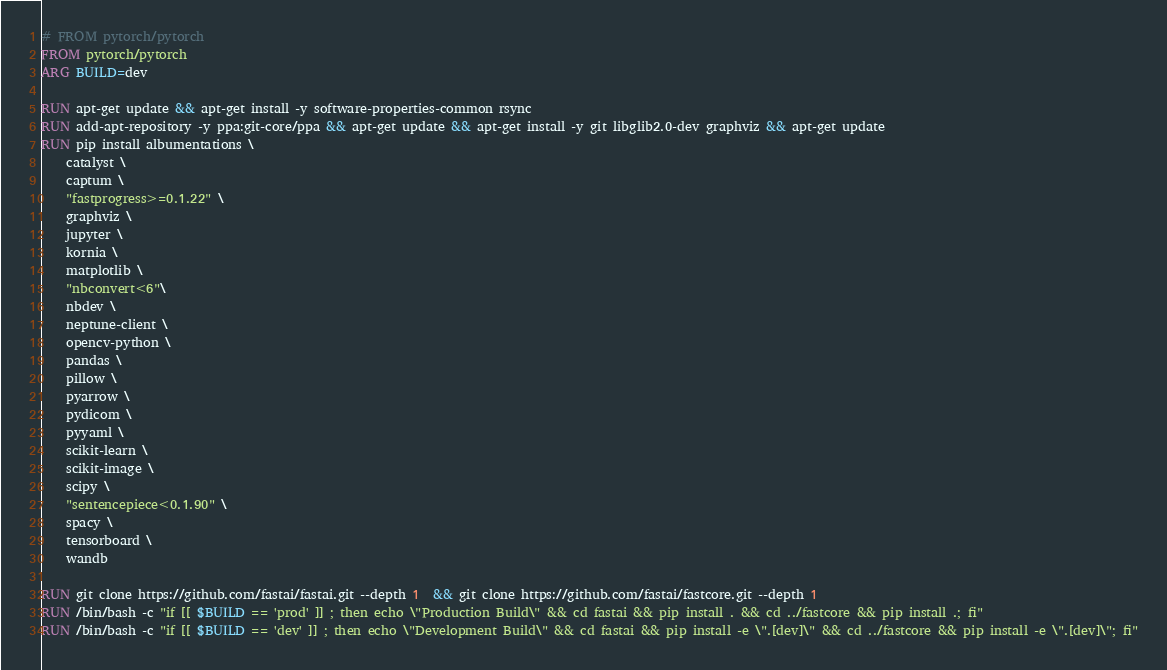<code> <loc_0><loc_0><loc_500><loc_500><_Dockerfile_># FROM pytorch/pytorch
FROM pytorch/pytorch
ARG BUILD=dev

RUN apt-get update && apt-get install -y software-properties-common rsync
RUN add-apt-repository -y ppa:git-core/ppa && apt-get update && apt-get install -y git libglib2.0-dev graphviz && apt-get update
RUN pip install albumentations \
    catalyst \
    captum \
    "fastprogress>=0.1.22" \
    graphviz \
    jupyter \
    kornia \
    matplotlib \
    "nbconvert<6"\
    nbdev \
    neptune-client \
    opencv-python \
    pandas \
    pillow \
    pyarrow \
    pydicom \
    pyyaml \
    scikit-learn \
    scikit-image \
    scipy \
    "sentencepiece<0.1.90" \
    spacy \
    tensorboard \
    wandb

RUN git clone https://github.com/fastai/fastai.git --depth 1  && git clone https://github.com/fastai/fastcore.git --depth 1
RUN /bin/bash -c "if [[ $BUILD == 'prod' ]] ; then echo \"Production Build\" && cd fastai && pip install . && cd ../fastcore && pip install .; fi"
RUN /bin/bash -c "if [[ $BUILD == 'dev' ]] ; then echo \"Development Build\" && cd fastai && pip install -e \".[dev]\" && cd ../fastcore && pip install -e \".[dev]\"; fi"</code> 